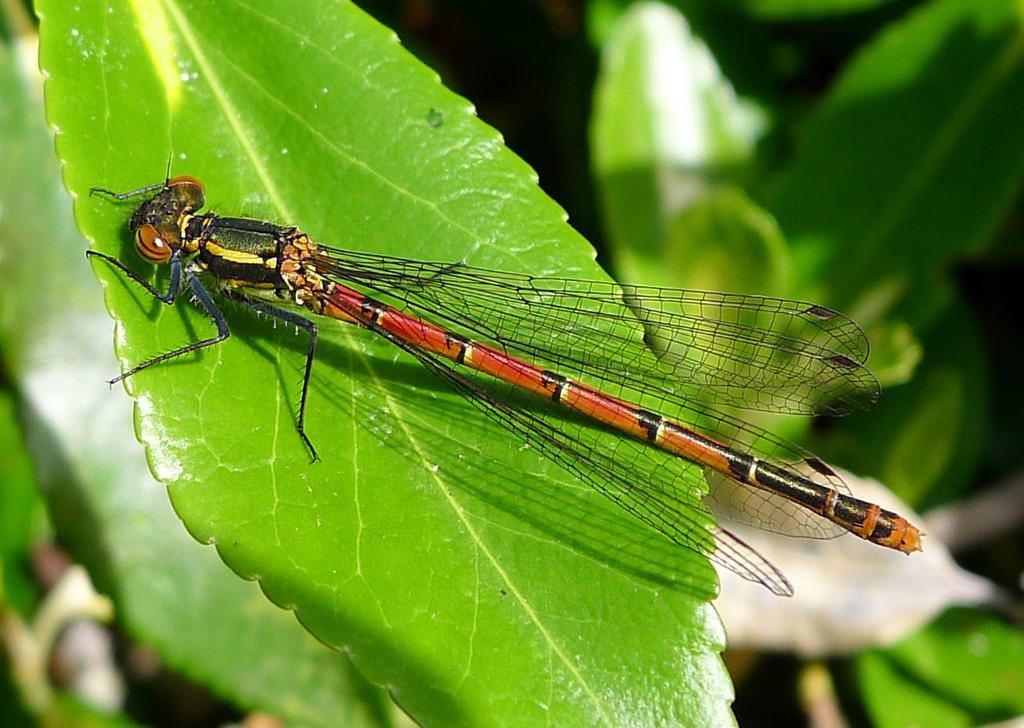What insect is present in the image? There is a dragonfly in the image. Where is the dragonfly located? The dragonfly is present on a leaf. What can be seen in the background of the image? Leaves are visible in the background of the image. What color is the skirt worn by the dragonfly in the image? There is no skirt present in the image, as dragonflies do not wear clothing. 